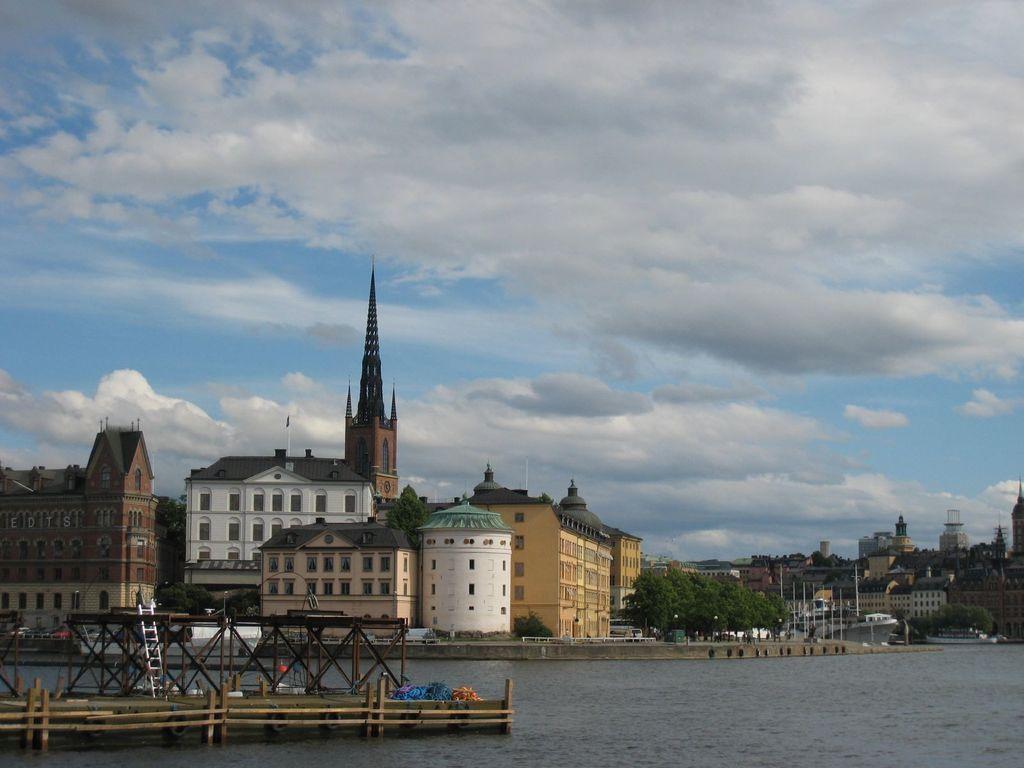In one or two sentences, can you explain what this image depicts? This is an outside view. At the bottom, I can see the water. On the left side there is a bridge and also there is a ladder. In the background there are many buildings and trees and also I can see the light poles. At the top of the image I can see the sky and clouds. 